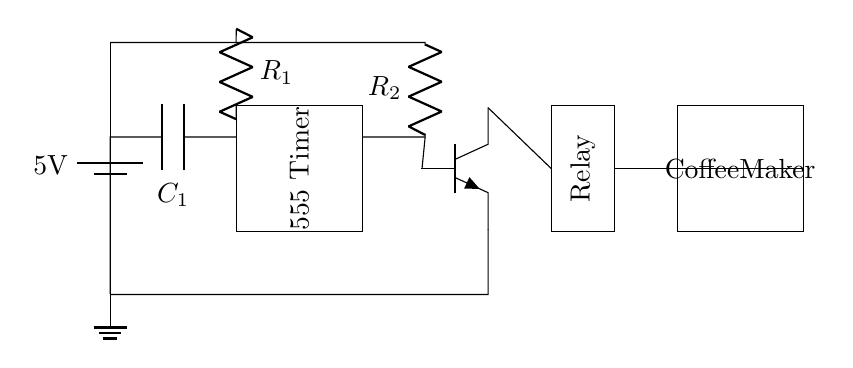What is the voltage of this circuit? The voltage is connected across the battery, which is labeled as 5V. This indicates the operating voltage for the circuit.
Answer: 5V What component is used to control timing? The 555 Timer is a well-known integrated circuit used in this design to control timing functions. It is shown as a rectangular box labeled "555 Timer."
Answer: 555 Timer What type of transistor is present in this circuit? The circuit features an NPN transistor indicated by the symbol with three leads: emitter, base, and collector. This type is commonly used for switching applications.
Answer: NPN Which component activates the coffee maker? The relay is responsible for activating the coffee maker by controlling the electrical connection. It is marked in the diagram and connects to both the transistor and the coffee maker.
Answer: Relay What is the function of the capacitor in this circuit? The capacitor, labeled as C1, is used for timing in conjunction with the resistor R1. It can store and release electrical energy, affecting how long the timer runs.
Answer: Timing 